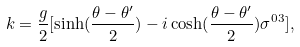Convert formula to latex. <formula><loc_0><loc_0><loc_500><loc_500>k = \frac { g } { 2 } [ \sinh ( \frac { \theta - \theta ^ { \prime } } { 2 } ) - i \cosh ( \frac { \theta - \theta ^ { \prime } } { 2 } ) \sigma ^ { 0 3 } ] ,</formula> 